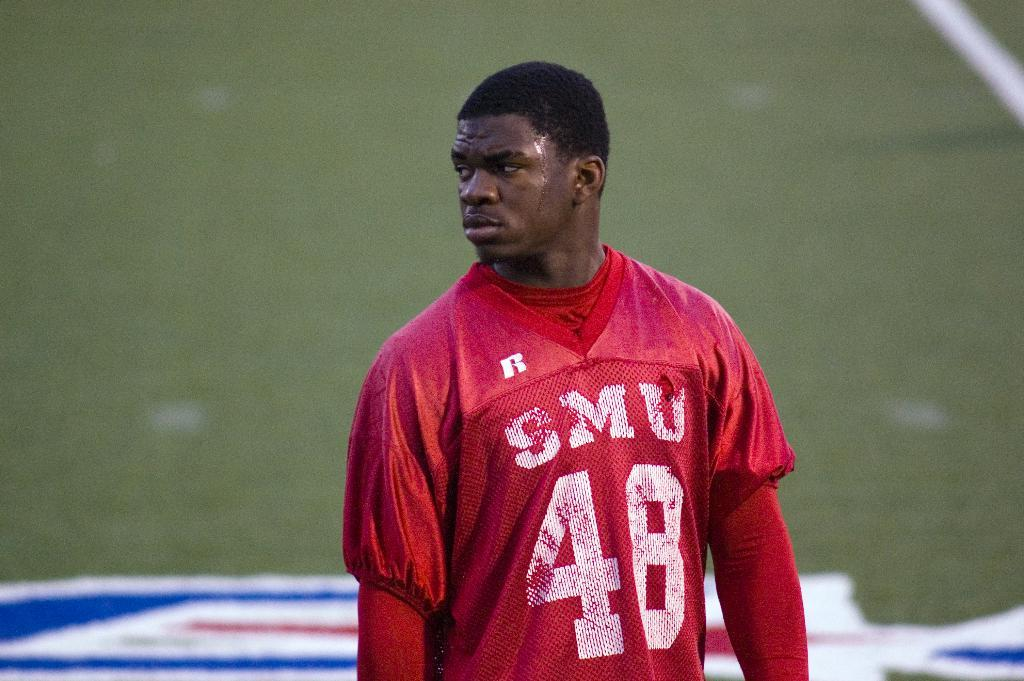<image>
Write a terse but informative summary of the picture. SMU player number forty eight stands on the field wearing a red jersey. 